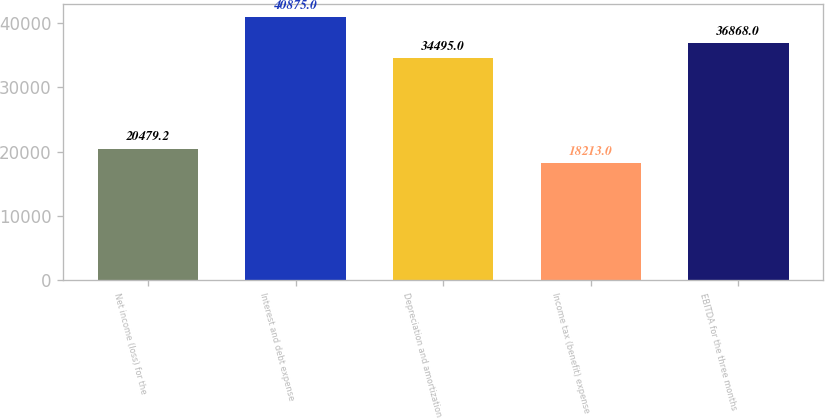Convert chart. <chart><loc_0><loc_0><loc_500><loc_500><bar_chart><fcel>Net income (loss) for the<fcel>Interest and debt expense<fcel>Depreciation and amortization<fcel>Income tax (benefit) expense<fcel>EBITDA for the three months<nl><fcel>20479.2<fcel>40875<fcel>34495<fcel>18213<fcel>36868<nl></chart> 